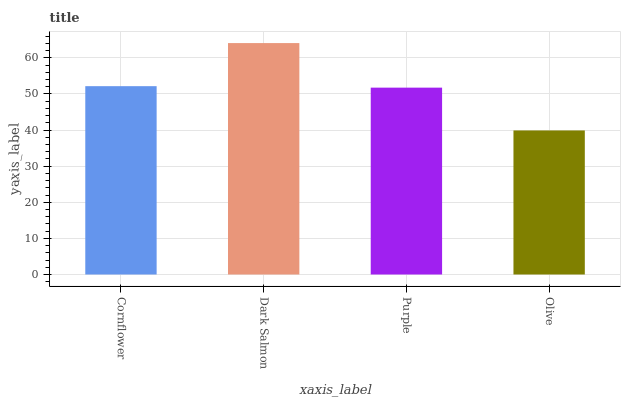Is Olive the minimum?
Answer yes or no. Yes. Is Dark Salmon the maximum?
Answer yes or no. Yes. Is Purple the minimum?
Answer yes or no. No. Is Purple the maximum?
Answer yes or no. No. Is Dark Salmon greater than Purple?
Answer yes or no. Yes. Is Purple less than Dark Salmon?
Answer yes or no. Yes. Is Purple greater than Dark Salmon?
Answer yes or no. No. Is Dark Salmon less than Purple?
Answer yes or no. No. Is Cornflower the high median?
Answer yes or no. Yes. Is Purple the low median?
Answer yes or no. Yes. Is Olive the high median?
Answer yes or no. No. Is Dark Salmon the low median?
Answer yes or no. No. 